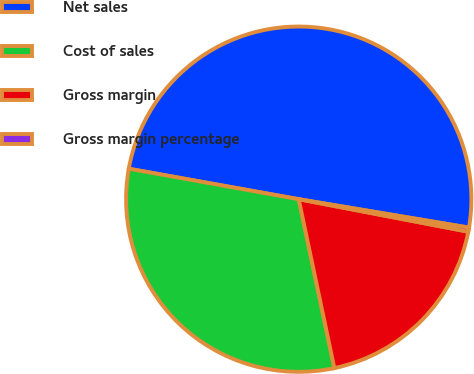<chart> <loc_0><loc_0><loc_500><loc_500><pie_chart><fcel>Net sales<fcel>Cost of sales<fcel>Gross margin<fcel>Gross margin percentage<nl><fcel>49.8%<fcel>31.13%<fcel>18.67%<fcel>0.39%<nl></chart> 